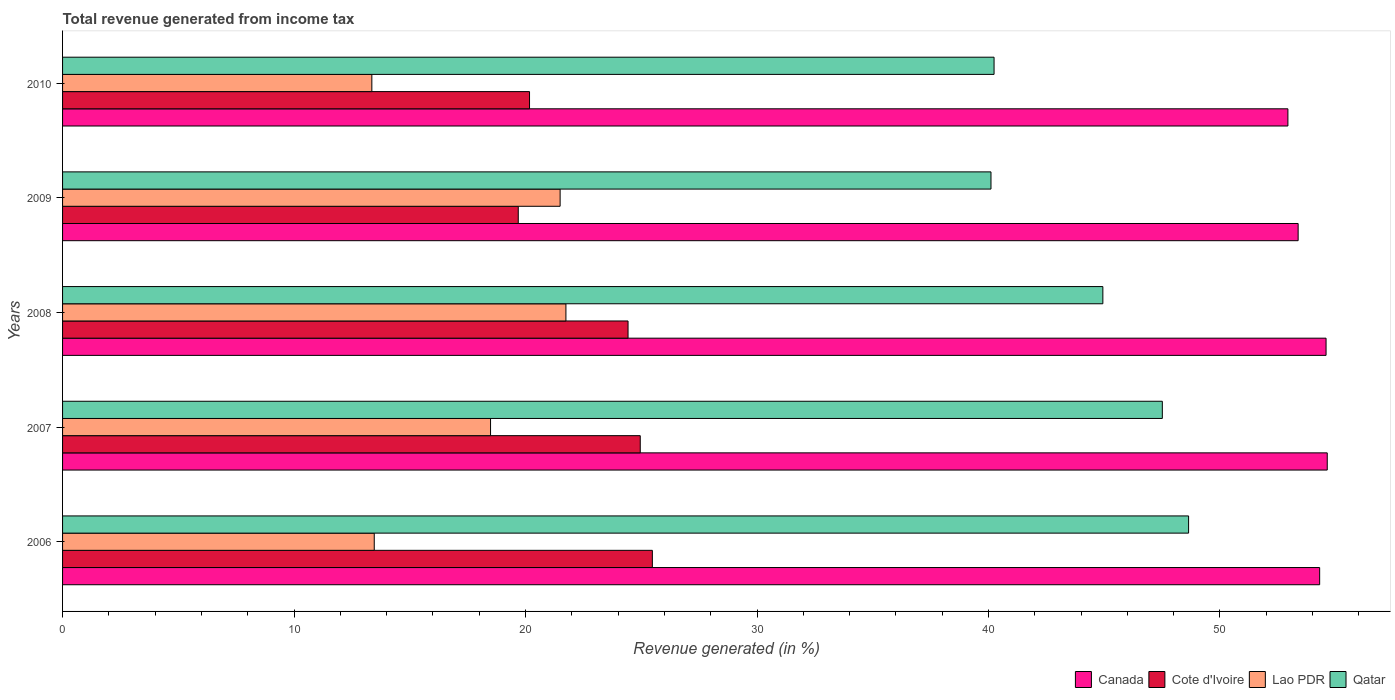How many different coloured bars are there?
Keep it short and to the point. 4. How many groups of bars are there?
Make the answer very short. 5. Are the number of bars on each tick of the Y-axis equal?
Provide a succinct answer. Yes. How many bars are there on the 1st tick from the top?
Offer a terse response. 4. What is the label of the 1st group of bars from the top?
Ensure brevity in your answer.  2010. In how many cases, is the number of bars for a given year not equal to the number of legend labels?
Your response must be concise. 0. What is the total revenue generated in Canada in 2010?
Offer a terse response. 52.94. Across all years, what is the maximum total revenue generated in Cote d'Ivoire?
Offer a terse response. 25.48. Across all years, what is the minimum total revenue generated in Cote d'Ivoire?
Your answer should be compact. 19.69. In which year was the total revenue generated in Cote d'Ivoire maximum?
Keep it short and to the point. 2006. In which year was the total revenue generated in Canada minimum?
Keep it short and to the point. 2010. What is the total total revenue generated in Qatar in the graph?
Provide a succinct answer. 221.45. What is the difference between the total revenue generated in Lao PDR in 2009 and that in 2010?
Ensure brevity in your answer.  8.13. What is the difference between the total revenue generated in Cote d'Ivoire in 2006 and the total revenue generated in Lao PDR in 2009?
Your response must be concise. 3.98. What is the average total revenue generated in Qatar per year?
Make the answer very short. 44.29. In the year 2008, what is the difference between the total revenue generated in Cote d'Ivoire and total revenue generated in Canada?
Make the answer very short. -30.15. In how many years, is the total revenue generated in Cote d'Ivoire greater than 6 %?
Make the answer very short. 5. What is the ratio of the total revenue generated in Qatar in 2007 to that in 2008?
Your answer should be compact. 1.06. Is the difference between the total revenue generated in Cote d'Ivoire in 2006 and 2007 greater than the difference between the total revenue generated in Canada in 2006 and 2007?
Keep it short and to the point. Yes. What is the difference between the highest and the second highest total revenue generated in Lao PDR?
Make the answer very short. 0.25. What is the difference between the highest and the lowest total revenue generated in Cote d'Ivoire?
Give a very brief answer. 5.79. Is the sum of the total revenue generated in Cote d'Ivoire in 2008 and 2009 greater than the maximum total revenue generated in Qatar across all years?
Offer a terse response. No. What does the 2nd bar from the top in 2007 represents?
Keep it short and to the point. Lao PDR. What does the 3rd bar from the bottom in 2008 represents?
Your answer should be compact. Lao PDR. Is it the case that in every year, the sum of the total revenue generated in Canada and total revenue generated in Qatar is greater than the total revenue generated in Lao PDR?
Offer a terse response. Yes. Are all the bars in the graph horizontal?
Provide a short and direct response. Yes. What is the difference between two consecutive major ticks on the X-axis?
Your answer should be compact. 10. Does the graph contain any zero values?
Your answer should be compact. No. How many legend labels are there?
Ensure brevity in your answer.  4. How are the legend labels stacked?
Your answer should be compact. Horizontal. What is the title of the graph?
Your response must be concise. Total revenue generated from income tax. What is the label or title of the X-axis?
Keep it short and to the point. Revenue generated (in %). What is the Revenue generated (in %) of Canada in 2006?
Your answer should be compact. 54.31. What is the Revenue generated (in %) in Cote d'Ivoire in 2006?
Your response must be concise. 25.48. What is the Revenue generated (in %) of Lao PDR in 2006?
Provide a short and direct response. 13.46. What is the Revenue generated (in %) in Qatar in 2006?
Your answer should be compact. 48.64. What is the Revenue generated (in %) of Canada in 2007?
Your answer should be compact. 54.64. What is the Revenue generated (in %) in Cote d'Ivoire in 2007?
Your response must be concise. 24.96. What is the Revenue generated (in %) in Lao PDR in 2007?
Make the answer very short. 18.49. What is the Revenue generated (in %) in Qatar in 2007?
Make the answer very short. 47.51. What is the Revenue generated (in %) of Canada in 2008?
Your response must be concise. 54.58. What is the Revenue generated (in %) of Cote d'Ivoire in 2008?
Keep it short and to the point. 24.43. What is the Revenue generated (in %) in Lao PDR in 2008?
Keep it short and to the point. 21.74. What is the Revenue generated (in %) in Qatar in 2008?
Provide a short and direct response. 44.94. What is the Revenue generated (in %) in Canada in 2009?
Your response must be concise. 53.38. What is the Revenue generated (in %) in Cote d'Ivoire in 2009?
Give a very brief answer. 19.69. What is the Revenue generated (in %) of Lao PDR in 2009?
Give a very brief answer. 21.49. What is the Revenue generated (in %) in Qatar in 2009?
Give a very brief answer. 40.11. What is the Revenue generated (in %) in Canada in 2010?
Ensure brevity in your answer.  52.94. What is the Revenue generated (in %) of Cote d'Ivoire in 2010?
Provide a succinct answer. 20.17. What is the Revenue generated (in %) in Lao PDR in 2010?
Your response must be concise. 13.36. What is the Revenue generated (in %) in Qatar in 2010?
Your answer should be compact. 40.24. Across all years, what is the maximum Revenue generated (in %) in Canada?
Provide a succinct answer. 54.64. Across all years, what is the maximum Revenue generated (in %) in Cote d'Ivoire?
Give a very brief answer. 25.48. Across all years, what is the maximum Revenue generated (in %) in Lao PDR?
Offer a very short reply. 21.74. Across all years, what is the maximum Revenue generated (in %) in Qatar?
Your answer should be very brief. 48.64. Across all years, what is the minimum Revenue generated (in %) of Canada?
Give a very brief answer. 52.94. Across all years, what is the minimum Revenue generated (in %) in Cote d'Ivoire?
Offer a terse response. 19.69. Across all years, what is the minimum Revenue generated (in %) of Lao PDR?
Your answer should be very brief. 13.36. Across all years, what is the minimum Revenue generated (in %) of Qatar?
Provide a succinct answer. 40.11. What is the total Revenue generated (in %) of Canada in the graph?
Offer a very short reply. 269.84. What is the total Revenue generated (in %) in Cote d'Ivoire in the graph?
Offer a very short reply. 114.72. What is the total Revenue generated (in %) in Lao PDR in the graph?
Make the answer very short. 88.55. What is the total Revenue generated (in %) in Qatar in the graph?
Your answer should be very brief. 221.45. What is the difference between the Revenue generated (in %) of Canada in 2006 and that in 2007?
Keep it short and to the point. -0.33. What is the difference between the Revenue generated (in %) in Cote d'Ivoire in 2006 and that in 2007?
Make the answer very short. 0.52. What is the difference between the Revenue generated (in %) of Lao PDR in 2006 and that in 2007?
Your answer should be compact. -5.02. What is the difference between the Revenue generated (in %) of Qatar in 2006 and that in 2007?
Your response must be concise. 1.13. What is the difference between the Revenue generated (in %) of Canada in 2006 and that in 2008?
Offer a terse response. -0.28. What is the difference between the Revenue generated (in %) in Cote d'Ivoire in 2006 and that in 2008?
Your answer should be very brief. 1.05. What is the difference between the Revenue generated (in %) of Lao PDR in 2006 and that in 2008?
Provide a short and direct response. -8.28. What is the difference between the Revenue generated (in %) in Qatar in 2006 and that in 2008?
Your answer should be very brief. 3.7. What is the difference between the Revenue generated (in %) of Canada in 2006 and that in 2009?
Offer a terse response. 0.93. What is the difference between the Revenue generated (in %) of Cote d'Ivoire in 2006 and that in 2009?
Your answer should be compact. 5.79. What is the difference between the Revenue generated (in %) of Lao PDR in 2006 and that in 2009?
Provide a short and direct response. -8.03. What is the difference between the Revenue generated (in %) of Qatar in 2006 and that in 2009?
Give a very brief answer. 8.54. What is the difference between the Revenue generated (in %) in Canada in 2006 and that in 2010?
Your response must be concise. 1.37. What is the difference between the Revenue generated (in %) in Cote d'Ivoire in 2006 and that in 2010?
Ensure brevity in your answer.  5.31. What is the difference between the Revenue generated (in %) in Lao PDR in 2006 and that in 2010?
Offer a terse response. 0.1. What is the difference between the Revenue generated (in %) of Qatar in 2006 and that in 2010?
Your answer should be compact. 8.4. What is the difference between the Revenue generated (in %) in Canada in 2007 and that in 2008?
Your answer should be very brief. 0.05. What is the difference between the Revenue generated (in %) of Cote d'Ivoire in 2007 and that in 2008?
Your answer should be very brief. 0.53. What is the difference between the Revenue generated (in %) of Lao PDR in 2007 and that in 2008?
Offer a terse response. -3.26. What is the difference between the Revenue generated (in %) of Qatar in 2007 and that in 2008?
Your response must be concise. 2.57. What is the difference between the Revenue generated (in %) of Canada in 2007 and that in 2009?
Offer a terse response. 1.26. What is the difference between the Revenue generated (in %) in Cote d'Ivoire in 2007 and that in 2009?
Provide a succinct answer. 5.27. What is the difference between the Revenue generated (in %) of Lao PDR in 2007 and that in 2009?
Your response must be concise. -3.01. What is the difference between the Revenue generated (in %) of Qatar in 2007 and that in 2009?
Offer a terse response. 7.4. What is the difference between the Revenue generated (in %) of Canada in 2007 and that in 2010?
Give a very brief answer. 1.7. What is the difference between the Revenue generated (in %) of Cote d'Ivoire in 2007 and that in 2010?
Keep it short and to the point. 4.78. What is the difference between the Revenue generated (in %) of Lao PDR in 2007 and that in 2010?
Make the answer very short. 5.13. What is the difference between the Revenue generated (in %) of Qatar in 2007 and that in 2010?
Your response must be concise. 7.27. What is the difference between the Revenue generated (in %) of Canada in 2008 and that in 2009?
Give a very brief answer. 1.21. What is the difference between the Revenue generated (in %) in Cote d'Ivoire in 2008 and that in 2009?
Your answer should be very brief. 4.74. What is the difference between the Revenue generated (in %) of Lao PDR in 2008 and that in 2009?
Ensure brevity in your answer.  0.25. What is the difference between the Revenue generated (in %) in Qatar in 2008 and that in 2009?
Offer a very short reply. 4.83. What is the difference between the Revenue generated (in %) of Canada in 2008 and that in 2010?
Offer a very short reply. 1.65. What is the difference between the Revenue generated (in %) in Cote d'Ivoire in 2008 and that in 2010?
Keep it short and to the point. 4.26. What is the difference between the Revenue generated (in %) of Lao PDR in 2008 and that in 2010?
Offer a terse response. 8.38. What is the difference between the Revenue generated (in %) in Qatar in 2008 and that in 2010?
Make the answer very short. 4.7. What is the difference between the Revenue generated (in %) in Canada in 2009 and that in 2010?
Keep it short and to the point. 0.44. What is the difference between the Revenue generated (in %) of Cote d'Ivoire in 2009 and that in 2010?
Make the answer very short. -0.49. What is the difference between the Revenue generated (in %) in Lao PDR in 2009 and that in 2010?
Offer a very short reply. 8.13. What is the difference between the Revenue generated (in %) of Qatar in 2009 and that in 2010?
Offer a terse response. -0.13. What is the difference between the Revenue generated (in %) of Canada in 2006 and the Revenue generated (in %) of Cote d'Ivoire in 2007?
Offer a very short reply. 29.35. What is the difference between the Revenue generated (in %) of Canada in 2006 and the Revenue generated (in %) of Lao PDR in 2007?
Make the answer very short. 35.82. What is the difference between the Revenue generated (in %) of Canada in 2006 and the Revenue generated (in %) of Qatar in 2007?
Keep it short and to the point. 6.8. What is the difference between the Revenue generated (in %) in Cote d'Ivoire in 2006 and the Revenue generated (in %) in Lao PDR in 2007?
Offer a terse response. 6.99. What is the difference between the Revenue generated (in %) in Cote d'Ivoire in 2006 and the Revenue generated (in %) in Qatar in 2007?
Keep it short and to the point. -22.03. What is the difference between the Revenue generated (in %) of Lao PDR in 2006 and the Revenue generated (in %) of Qatar in 2007?
Make the answer very short. -34.05. What is the difference between the Revenue generated (in %) of Canada in 2006 and the Revenue generated (in %) of Cote d'Ivoire in 2008?
Ensure brevity in your answer.  29.88. What is the difference between the Revenue generated (in %) of Canada in 2006 and the Revenue generated (in %) of Lao PDR in 2008?
Your response must be concise. 32.56. What is the difference between the Revenue generated (in %) of Canada in 2006 and the Revenue generated (in %) of Qatar in 2008?
Ensure brevity in your answer.  9.37. What is the difference between the Revenue generated (in %) in Cote d'Ivoire in 2006 and the Revenue generated (in %) in Lao PDR in 2008?
Offer a very short reply. 3.73. What is the difference between the Revenue generated (in %) of Cote d'Ivoire in 2006 and the Revenue generated (in %) of Qatar in 2008?
Give a very brief answer. -19.46. What is the difference between the Revenue generated (in %) of Lao PDR in 2006 and the Revenue generated (in %) of Qatar in 2008?
Provide a succinct answer. -31.48. What is the difference between the Revenue generated (in %) in Canada in 2006 and the Revenue generated (in %) in Cote d'Ivoire in 2009?
Ensure brevity in your answer.  34.62. What is the difference between the Revenue generated (in %) of Canada in 2006 and the Revenue generated (in %) of Lao PDR in 2009?
Your answer should be very brief. 32.81. What is the difference between the Revenue generated (in %) in Canada in 2006 and the Revenue generated (in %) in Qatar in 2009?
Ensure brevity in your answer.  14.2. What is the difference between the Revenue generated (in %) in Cote d'Ivoire in 2006 and the Revenue generated (in %) in Lao PDR in 2009?
Offer a very short reply. 3.98. What is the difference between the Revenue generated (in %) in Cote d'Ivoire in 2006 and the Revenue generated (in %) in Qatar in 2009?
Keep it short and to the point. -14.63. What is the difference between the Revenue generated (in %) in Lao PDR in 2006 and the Revenue generated (in %) in Qatar in 2009?
Offer a terse response. -26.64. What is the difference between the Revenue generated (in %) of Canada in 2006 and the Revenue generated (in %) of Cote d'Ivoire in 2010?
Offer a terse response. 34.13. What is the difference between the Revenue generated (in %) of Canada in 2006 and the Revenue generated (in %) of Lao PDR in 2010?
Make the answer very short. 40.95. What is the difference between the Revenue generated (in %) of Canada in 2006 and the Revenue generated (in %) of Qatar in 2010?
Your answer should be very brief. 14.07. What is the difference between the Revenue generated (in %) of Cote d'Ivoire in 2006 and the Revenue generated (in %) of Lao PDR in 2010?
Your answer should be compact. 12.12. What is the difference between the Revenue generated (in %) of Cote d'Ivoire in 2006 and the Revenue generated (in %) of Qatar in 2010?
Your answer should be very brief. -14.76. What is the difference between the Revenue generated (in %) in Lao PDR in 2006 and the Revenue generated (in %) in Qatar in 2010?
Your answer should be very brief. -26.78. What is the difference between the Revenue generated (in %) of Canada in 2007 and the Revenue generated (in %) of Cote d'Ivoire in 2008?
Make the answer very short. 30.21. What is the difference between the Revenue generated (in %) in Canada in 2007 and the Revenue generated (in %) in Lao PDR in 2008?
Your answer should be compact. 32.89. What is the difference between the Revenue generated (in %) in Canada in 2007 and the Revenue generated (in %) in Qatar in 2008?
Your answer should be compact. 9.69. What is the difference between the Revenue generated (in %) in Cote d'Ivoire in 2007 and the Revenue generated (in %) in Lao PDR in 2008?
Your answer should be very brief. 3.21. What is the difference between the Revenue generated (in %) in Cote d'Ivoire in 2007 and the Revenue generated (in %) in Qatar in 2008?
Make the answer very short. -19.98. What is the difference between the Revenue generated (in %) of Lao PDR in 2007 and the Revenue generated (in %) of Qatar in 2008?
Provide a short and direct response. -26.45. What is the difference between the Revenue generated (in %) of Canada in 2007 and the Revenue generated (in %) of Cote d'Ivoire in 2009?
Your answer should be compact. 34.95. What is the difference between the Revenue generated (in %) of Canada in 2007 and the Revenue generated (in %) of Lao PDR in 2009?
Your answer should be compact. 33.14. What is the difference between the Revenue generated (in %) of Canada in 2007 and the Revenue generated (in %) of Qatar in 2009?
Ensure brevity in your answer.  14.53. What is the difference between the Revenue generated (in %) in Cote d'Ivoire in 2007 and the Revenue generated (in %) in Lao PDR in 2009?
Keep it short and to the point. 3.46. What is the difference between the Revenue generated (in %) of Cote d'Ivoire in 2007 and the Revenue generated (in %) of Qatar in 2009?
Give a very brief answer. -15.15. What is the difference between the Revenue generated (in %) in Lao PDR in 2007 and the Revenue generated (in %) in Qatar in 2009?
Provide a short and direct response. -21.62. What is the difference between the Revenue generated (in %) in Canada in 2007 and the Revenue generated (in %) in Cote d'Ivoire in 2010?
Your answer should be compact. 34.46. What is the difference between the Revenue generated (in %) of Canada in 2007 and the Revenue generated (in %) of Lao PDR in 2010?
Make the answer very short. 41.27. What is the difference between the Revenue generated (in %) in Canada in 2007 and the Revenue generated (in %) in Qatar in 2010?
Provide a succinct answer. 14.39. What is the difference between the Revenue generated (in %) of Cote d'Ivoire in 2007 and the Revenue generated (in %) of Lao PDR in 2010?
Ensure brevity in your answer.  11.6. What is the difference between the Revenue generated (in %) of Cote d'Ivoire in 2007 and the Revenue generated (in %) of Qatar in 2010?
Make the answer very short. -15.29. What is the difference between the Revenue generated (in %) in Lao PDR in 2007 and the Revenue generated (in %) in Qatar in 2010?
Your response must be concise. -21.75. What is the difference between the Revenue generated (in %) of Canada in 2008 and the Revenue generated (in %) of Cote d'Ivoire in 2009?
Your answer should be very brief. 34.9. What is the difference between the Revenue generated (in %) in Canada in 2008 and the Revenue generated (in %) in Lao PDR in 2009?
Ensure brevity in your answer.  33.09. What is the difference between the Revenue generated (in %) in Canada in 2008 and the Revenue generated (in %) in Qatar in 2009?
Your answer should be very brief. 14.47. What is the difference between the Revenue generated (in %) of Cote d'Ivoire in 2008 and the Revenue generated (in %) of Lao PDR in 2009?
Ensure brevity in your answer.  2.93. What is the difference between the Revenue generated (in %) of Cote d'Ivoire in 2008 and the Revenue generated (in %) of Qatar in 2009?
Make the answer very short. -15.68. What is the difference between the Revenue generated (in %) in Lao PDR in 2008 and the Revenue generated (in %) in Qatar in 2009?
Your answer should be very brief. -18.36. What is the difference between the Revenue generated (in %) in Canada in 2008 and the Revenue generated (in %) in Cote d'Ivoire in 2010?
Keep it short and to the point. 34.41. What is the difference between the Revenue generated (in %) in Canada in 2008 and the Revenue generated (in %) in Lao PDR in 2010?
Provide a short and direct response. 41.22. What is the difference between the Revenue generated (in %) of Canada in 2008 and the Revenue generated (in %) of Qatar in 2010?
Your answer should be very brief. 14.34. What is the difference between the Revenue generated (in %) of Cote d'Ivoire in 2008 and the Revenue generated (in %) of Lao PDR in 2010?
Your response must be concise. 11.07. What is the difference between the Revenue generated (in %) in Cote d'Ivoire in 2008 and the Revenue generated (in %) in Qatar in 2010?
Provide a succinct answer. -15.81. What is the difference between the Revenue generated (in %) of Lao PDR in 2008 and the Revenue generated (in %) of Qatar in 2010?
Your response must be concise. -18.5. What is the difference between the Revenue generated (in %) in Canada in 2009 and the Revenue generated (in %) in Cote d'Ivoire in 2010?
Provide a succinct answer. 33.2. What is the difference between the Revenue generated (in %) of Canada in 2009 and the Revenue generated (in %) of Lao PDR in 2010?
Offer a very short reply. 40.02. What is the difference between the Revenue generated (in %) in Canada in 2009 and the Revenue generated (in %) in Qatar in 2010?
Offer a very short reply. 13.14. What is the difference between the Revenue generated (in %) of Cote d'Ivoire in 2009 and the Revenue generated (in %) of Lao PDR in 2010?
Make the answer very short. 6.33. What is the difference between the Revenue generated (in %) of Cote d'Ivoire in 2009 and the Revenue generated (in %) of Qatar in 2010?
Give a very brief answer. -20.56. What is the difference between the Revenue generated (in %) in Lao PDR in 2009 and the Revenue generated (in %) in Qatar in 2010?
Provide a succinct answer. -18.75. What is the average Revenue generated (in %) of Canada per year?
Make the answer very short. 53.97. What is the average Revenue generated (in %) of Cote d'Ivoire per year?
Offer a very short reply. 22.94. What is the average Revenue generated (in %) in Lao PDR per year?
Offer a terse response. 17.71. What is the average Revenue generated (in %) of Qatar per year?
Offer a terse response. 44.29. In the year 2006, what is the difference between the Revenue generated (in %) of Canada and Revenue generated (in %) of Cote d'Ivoire?
Provide a short and direct response. 28.83. In the year 2006, what is the difference between the Revenue generated (in %) in Canada and Revenue generated (in %) in Lao PDR?
Your answer should be compact. 40.84. In the year 2006, what is the difference between the Revenue generated (in %) of Canada and Revenue generated (in %) of Qatar?
Provide a succinct answer. 5.66. In the year 2006, what is the difference between the Revenue generated (in %) in Cote d'Ivoire and Revenue generated (in %) in Lao PDR?
Ensure brevity in your answer.  12.01. In the year 2006, what is the difference between the Revenue generated (in %) of Cote d'Ivoire and Revenue generated (in %) of Qatar?
Your response must be concise. -23.17. In the year 2006, what is the difference between the Revenue generated (in %) of Lao PDR and Revenue generated (in %) of Qatar?
Your answer should be compact. -35.18. In the year 2007, what is the difference between the Revenue generated (in %) in Canada and Revenue generated (in %) in Cote d'Ivoire?
Offer a very short reply. 29.68. In the year 2007, what is the difference between the Revenue generated (in %) in Canada and Revenue generated (in %) in Lao PDR?
Your answer should be very brief. 36.15. In the year 2007, what is the difference between the Revenue generated (in %) of Canada and Revenue generated (in %) of Qatar?
Provide a succinct answer. 7.12. In the year 2007, what is the difference between the Revenue generated (in %) in Cote d'Ivoire and Revenue generated (in %) in Lao PDR?
Your answer should be compact. 6.47. In the year 2007, what is the difference between the Revenue generated (in %) in Cote d'Ivoire and Revenue generated (in %) in Qatar?
Your answer should be compact. -22.55. In the year 2007, what is the difference between the Revenue generated (in %) of Lao PDR and Revenue generated (in %) of Qatar?
Offer a very short reply. -29.02. In the year 2008, what is the difference between the Revenue generated (in %) of Canada and Revenue generated (in %) of Cote d'Ivoire?
Offer a very short reply. 30.15. In the year 2008, what is the difference between the Revenue generated (in %) of Canada and Revenue generated (in %) of Lao PDR?
Your response must be concise. 32.84. In the year 2008, what is the difference between the Revenue generated (in %) of Canada and Revenue generated (in %) of Qatar?
Your answer should be compact. 9.64. In the year 2008, what is the difference between the Revenue generated (in %) of Cote d'Ivoire and Revenue generated (in %) of Lao PDR?
Make the answer very short. 2.68. In the year 2008, what is the difference between the Revenue generated (in %) in Cote d'Ivoire and Revenue generated (in %) in Qatar?
Keep it short and to the point. -20.51. In the year 2008, what is the difference between the Revenue generated (in %) in Lao PDR and Revenue generated (in %) in Qatar?
Your response must be concise. -23.2. In the year 2009, what is the difference between the Revenue generated (in %) of Canada and Revenue generated (in %) of Cote d'Ivoire?
Provide a short and direct response. 33.69. In the year 2009, what is the difference between the Revenue generated (in %) in Canada and Revenue generated (in %) in Lao PDR?
Offer a very short reply. 31.88. In the year 2009, what is the difference between the Revenue generated (in %) in Canada and Revenue generated (in %) in Qatar?
Offer a very short reply. 13.27. In the year 2009, what is the difference between the Revenue generated (in %) of Cote d'Ivoire and Revenue generated (in %) of Lao PDR?
Provide a succinct answer. -1.81. In the year 2009, what is the difference between the Revenue generated (in %) in Cote d'Ivoire and Revenue generated (in %) in Qatar?
Offer a very short reply. -20.42. In the year 2009, what is the difference between the Revenue generated (in %) of Lao PDR and Revenue generated (in %) of Qatar?
Make the answer very short. -18.61. In the year 2010, what is the difference between the Revenue generated (in %) in Canada and Revenue generated (in %) in Cote d'Ivoire?
Your answer should be very brief. 32.76. In the year 2010, what is the difference between the Revenue generated (in %) of Canada and Revenue generated (in %) of Lao PDR?
Provide a short and direct response. 39.57. In the year 2010, what is the difference between the Revenue generated (in %) in Canada and Revenue generated (in %) in Qatar?
Ensure brevity in your answer.  12.69. In the year 2010, what is the difference between the Revenue generated (in %) of Cote d'Ivoire and Revenue generated (in %) of Lao PDR?
Your answer should be compact. 6.81. In the year 2010, what is the difference between the Revenue generated (in %) of Cote d'Ivoire and Revenue generated (in %) of Qatar?
Your response must be concise. -20.07. In the year 2010, what is the difference between the Revenue generated (in %) in Lao PDR and Revenue generated (in %) in Qatar?
Make the answer very short. -26.88. What is the ratio of the Revenue generated (in %) in Canada in 2006 to that in 2007?
Ensure brevity in your answer.  0.99. What is the ratio of the Revenue generated (in %) of Cote d'Ivoire in 2006 to that in 2007?
Keep it short and to the point. 1.02. What is the ratio of the Revenue generated (in %) of Lao PDR in 2006 to that in 2007?
Give a very brief answer. 0.73. What is the ratio of the Revenue generated (in %) in Qatar in 2006 to that in 2007?
Keep it short and to the point. 1.02. What is the ratio of the Revenue generated (in %) of Cote d'Ivoire in 2006 to that in 2008?
Your answer should be compact. 1.04. What is the ratio of the Revenue generated (in %) in Lao PDR in 2006 to that in 2008?
Your response must be concise. 0.62. What is the ratio of the Revenue generated (in %) of Qatar in 2006 to that in 2008?
Give a very brief answer. 1.08. What is the ratio of the Revenue generated (in %) in Canada in 2006 to that in 2009?
Your answer should be compact. 1.02. What is the ratio of the Revenue generated (in %) in Cote d'Ivoire in 2006 to that in 2009?
Keep it short and to the point. 1.29. What is the ratio of the Revenue generated (in %) of Lao PDR in 2006 to that in 2009?
Your answer should be very brief. 0.63. What is the ratio of the Revenue generated (in %) of Qatar in 2006 to that in 2009?
Offer a terse response. 1.21. What is the ratio of the Revenue generated (in %) of Canada in 2006 to that in 2010?
Offer a terse response. 1.03. What is the ratio of the Revenue generated (in %) of Cote d'Ivoire in 2006 to that in 2010?
Provide a succinct answer. 1.26. What is the ratio of the Revenue generated (in %) of Lao PDR in 2006 to that in 2010?
Make the answer very short. 1.01. What is the ratio of the Revenue generated (in %) in Qatar in 2006 to that in 2010?
Give a very brief answer. 1.21. What is the ratio of the Revenue generated (in %) of Cote d'Ivoire in 2007 to that in 2008?
Your answer should be very brief. 1.02. What is the ratio of the Revenue generated (in %) of Lao PDR in 2007 to that in 2008?
Provide a succinct answer. 0.85. What is the ratio of the Revenue generated (in %) of Qatar in 2007 to that in 2008?
Your response must be concise. 1.06. What is the ratio of the Revenue generated (in %) in Canada in 2007 to that in 2009?
Make the answer very short. 1.02. What is the ratio of the Revenue generated (in %) of Cote d'Ivoire in 2007 to that in 2009?
Make the answer very short. 1.27. What is the ratio of the Revenue generated (in %) in Lao PDR in 2007 to that in 2009?
Your response must be concise. 0.86. What is the ratio of the Revenue generated (in %) of Qatar in 2007 to that in 2009?
Provide a succinct answer. 1.18. What is the ratio of the Revenue generated (in %) in Canada in 2007 to that in 2010?
Keep it short and to the point. 1.03. What is the ratio of the Revenue generated (in %) of Cote d'Ivoire in 2007 to that in 2010?
Provide a short and direct response. 1.24. What is the ratio of the Revenue generated (in %) in Lao PDR in 2007 to that in 2010?
Provide a short and direct response. 1.38. What is the ratio of the Revenue generated (in %) in Qatar in 2007 to that in 2010?
Your answer should be very brief. 1.18. What is the ratio of the Revenue generated (in %) of Canada in 2008 to that in 2009?
Offer a terse response. 1.02. What is the ratio of the Revenue generated (in %) of Cote d'Ivoire in 2008 to that in 2009?
Give a very brief answer. 1.24. What is the ratio of the Revenue generated (in %) of Lao PDR in 2008 to that in 2009?
Provide a short and direct response. 1.01. What is the ratio of the Revenue generated (in %) of Qatar in 2008 to that in 2009?
Your response must be concise. 1.12. What is the ratio of the Revenue generated (in %) of Canada in 2008 to that in 2010?
Keep it short and to the point. 1.03. What is the ratio of the Revenue generated (in %) of Cote d'Ivoire in 2008 to that in 2010?
Your answer should be compact. 1.21. What is the ratio of the Revenue generated (in %) in Lao PDR in 2008 to that in 2010?
Offer a very short reply. 1.63. What is the ratio of the Revenue generated (in %) in Qatar in 2008 to that in 2010?
Your response must be concise. 1.12. What is the ratio of the Revenue generated (in %) in Canada in 2009 to that in 2010?
Provide a short and direct response. 1.01. What is the ratio of the Revenue generated (in %) of Cote d'Ivoire in 2009 to that in 2010?
Provide a short and direct response. 0.98. What is the ratio of the Revenue generated (in %) in Lao PDR in 2009 to that in 2010?
Make the answer very short. 1.61. What is the ratio of the Revenue generated (in %) of Qatar in 2009 to that in 2010?
Ensure brevity in your answer.  1. What is the difference between the highest and the second highest Revenue generated (in %) of Canada?
Your answer should be compact. 0.05. What is the difference between the highest and the second highest Revenue generated (in %) of Cote d'Ivoire?
Keep it short and to the point. 0.52. What is the difference between the highest and the second highest Revenue generated (in %) of Lao PDR?
Your answer should be compact. 0.25. What is the difference between the highest and the second highest Revenue generated (in %) of Qatar?
Make the answer very short. 1.13. What is the difference between the highest and the lowest Revenue generated (in %) of Canada?
Provide a succinct answer. 1.7. What is the difference between the highest and the lowest Revenue generated (in %) of Cote d'Ivoire?
Make the answer very short. 5.79. What is the difference between the highest and the lowest Revenue generated (in %) of Lao PDR?
Give a very brief answer. 8.38. What is the difference between the highest and the lowest Revenue generated (in %) in Qatar?
Provide a short and direct response. 8.54. 